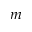<formula> <loc_0><loc_0><loc_500><loc_500>m</formula> 